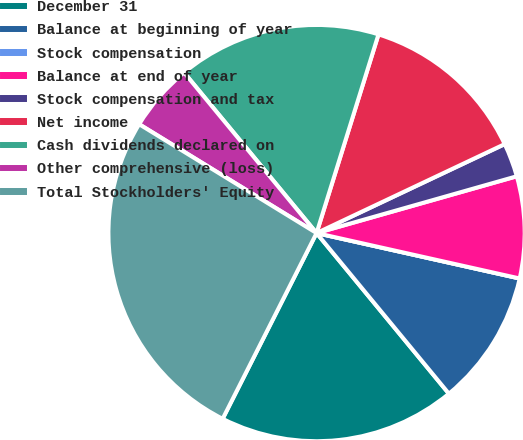<chart> <loc_0><loc_0><loc_500><loc_500><pie_chart><fcel>December 31<fcel>Balance at beginning of year<fcel>Stock compensation<fcel>Balance at end of year<fcel>Stock compensation and tax<fcel>Net income<fcel>Cash dividends declared on<fcel>Other comprehensive (loss)<fcel>Total Stockholders' Equity<nl><fcel>18.42%<fcel>10.53%<fcel>0.0%<fcel>7.9%<fcel>2.63%<fcel>13.16%<fcel>15.79%<fcel>5.26%<fcel>26.31%<nl></chart> 